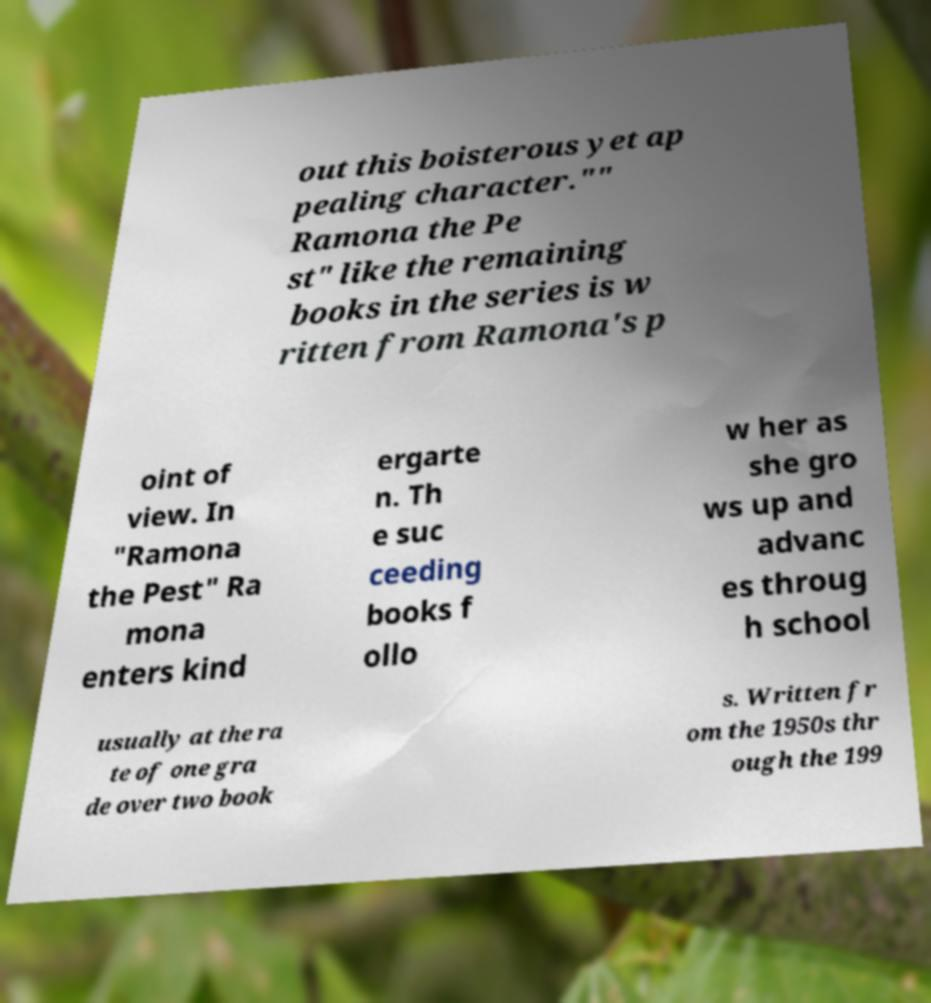Please identify and transcribe the text found in this image. out this boisterous yet ap pealing character."" Ramona the Pe st" like the remaining books in the series is w ritten from Ramona's p oint of view. In "Ramona the Pest" Ra mona enters kind ergarte n. Th e suc ceeding books f ollo w her as she gro ws up and advanc es throug h school usually at the ra te of one gra de over two book s. Written fr om the 1950s thr ough the 199 